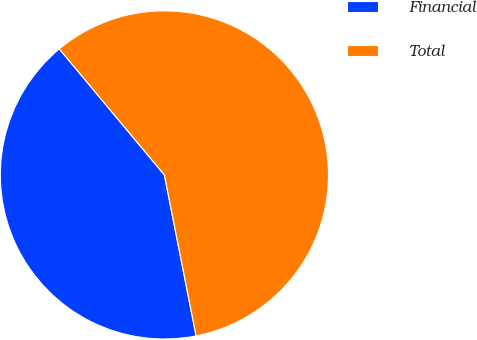Convert chart to OTSL. <chart><loc_0><loc_0><loc_500><loc_500><pie_chart><fcel>Financial<fcel>Total<nl><fcel>42.03%<fcel>57.97%<nl></chart> 